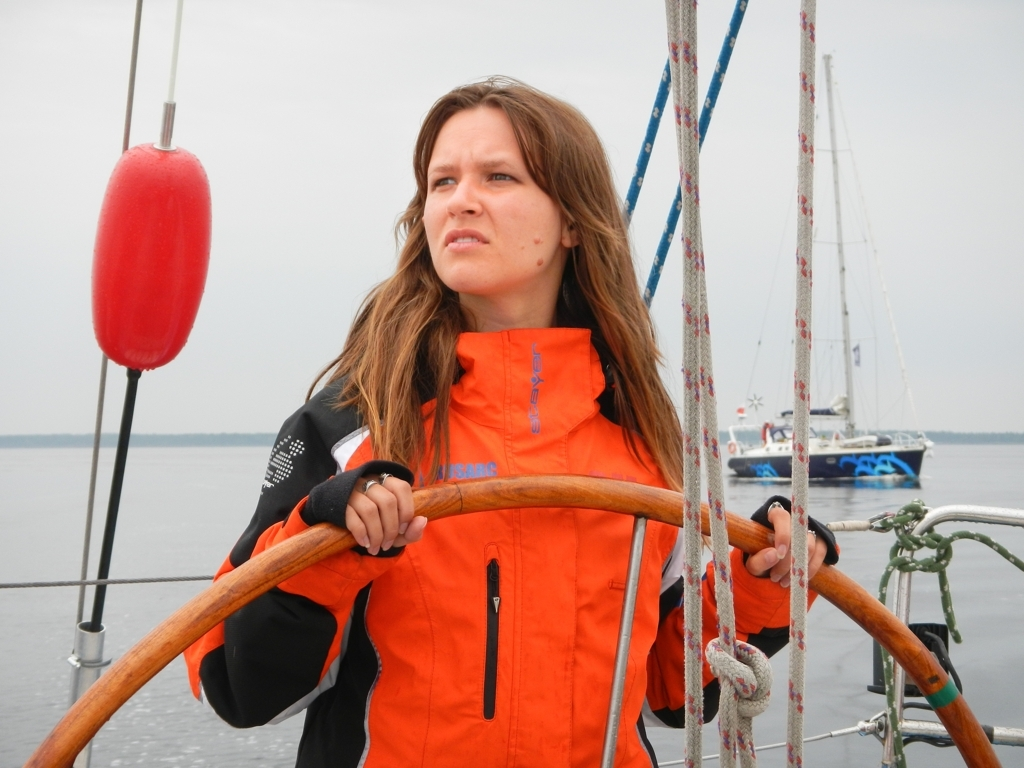What type of clothing is the person wearing and why might it be suitable for their environment? The individual is seen wearing an orange high-visibility waterproof jacket with reflective elements. Such attire is typically employed for safety and visibility in maritime settings, particularly beneficial in overcast weather or misty conditions to ensure the wearer stands out against the backdrop of the water and sky. 